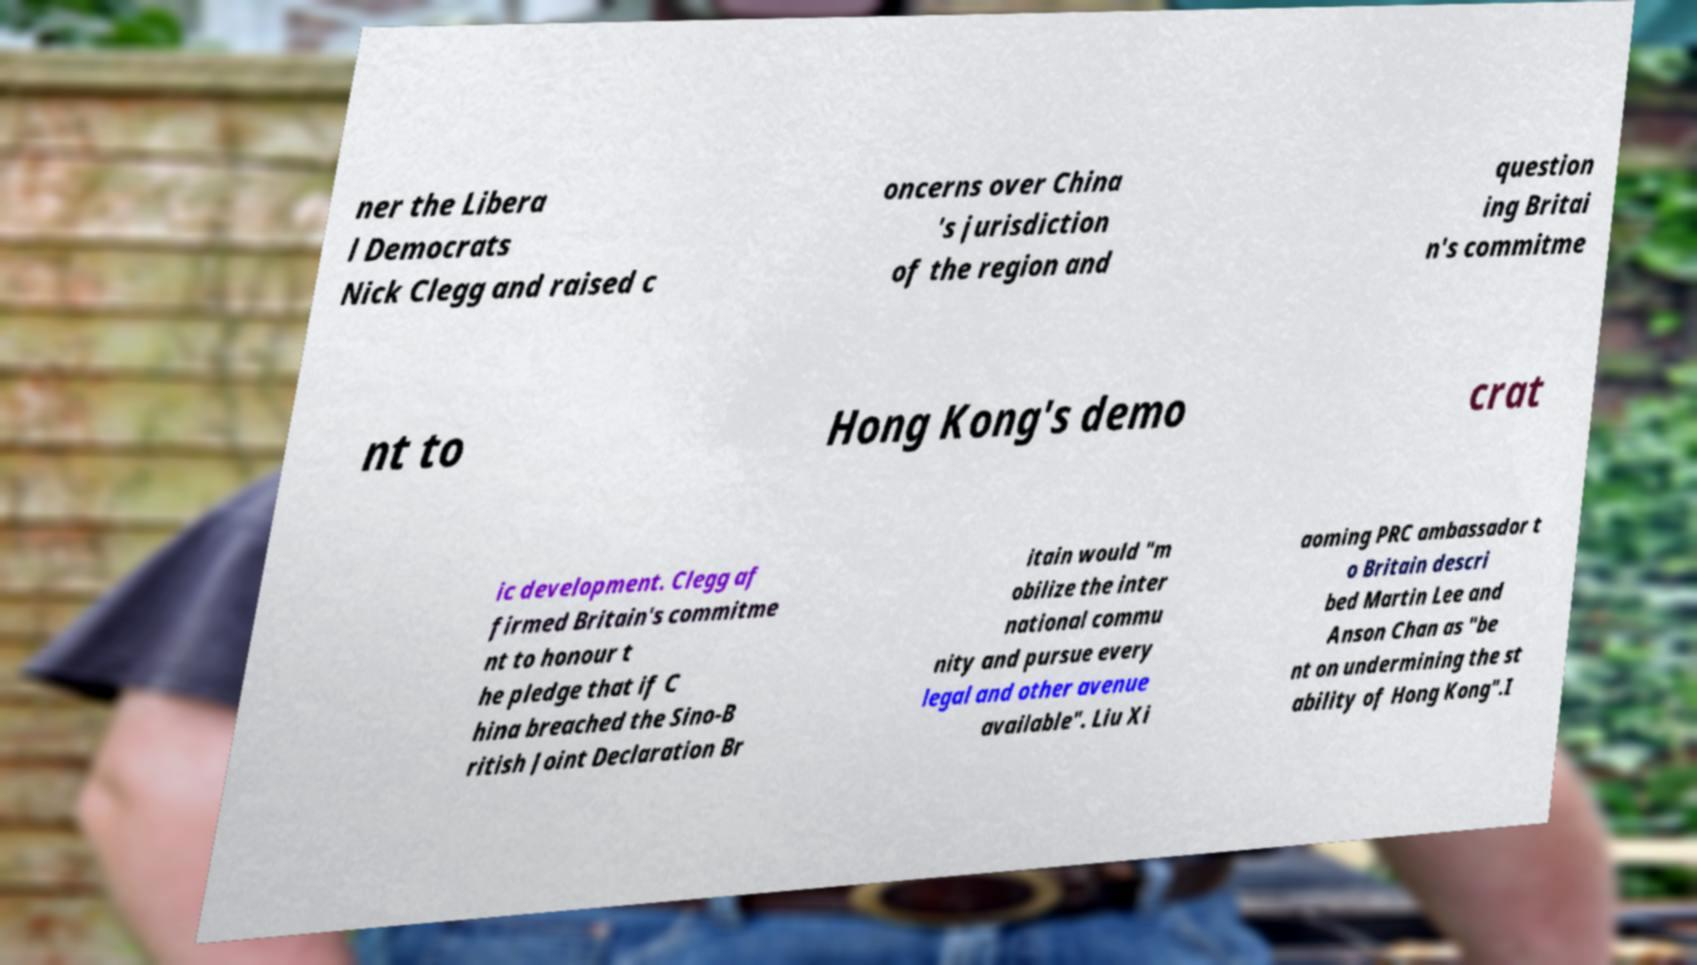For documentation purposes, I need the text within this image transcribed. Could you provide that? ner the Libera l Democrats Nick Clegg and raised c oncerns over China 's jurisdiction of the region and question ing Britai n's commitme nt to Hong Kong's demo crat ic development. Clegg af firmed Britain's commitme nt to honour t he pledge that if C hina breached the Sino-B ritish Joint Declaration Br itain would "m obilize the inter national commu nity and pursue every legal and other avenue available". Liu Xi aoming PRC ambassador t o Britain descri bed Martin Lee and Anson Chan as "be nt on undermining the st ability of Hong Kong".I 